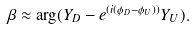Convert formula to latex. <formula><loc_0><loc_0><loc_500><loc_500>\beta \approx \arg ( { Y _ { D } } - e ^ { ( i ( { \phi _ { D } } - { \phi _ { U } } ) ) } { Y _ { U } } ) .</formula> 